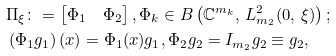<formula> <loc_0><loc_0><loc_500><loc_500>& \Pi _ { \xi } \colon = \begin{bmatrix} \Phi _ { 1 } & \Phi _ { 2 } \end{bmatrix} , \Phi _ { k } \in B \left ( \mathbb { C } ^ { m _ { k } } , \, L ^ { 2 } _ { m _ { 2 } } ( 0 , \, \xi ) \right ) ; \\ & \left ( \Phi _ { 1 } g _ { 1 } \right ) ( x ) = \Phi _ { 1 } ( x ) g _ { 1 } , \Phi _ { 2 } g _ { 2 } = I _ { m _ { 2 } } g _ { 2 } \equiv g _ { 2 } ,</formula> 